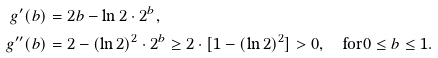Convert formula to latex. <formula><loc_0><loc_0><loc_500><loc_500>g ^ { \prime } ( b ) & = 2 b - \ln 2 \cdot 2 ^ { b } , \\ g ^ { \prime \prime } ( b ) & = 2 - ( \ln 2 ) ^ { 2 } \cdot 2 ^ { b } \geq 2 \cdot [ 1 - ( \ln 2 ) ^ { 2 } ] > 0 , \quad \text {for} 0 \leq b \leq 1 .</formula> 